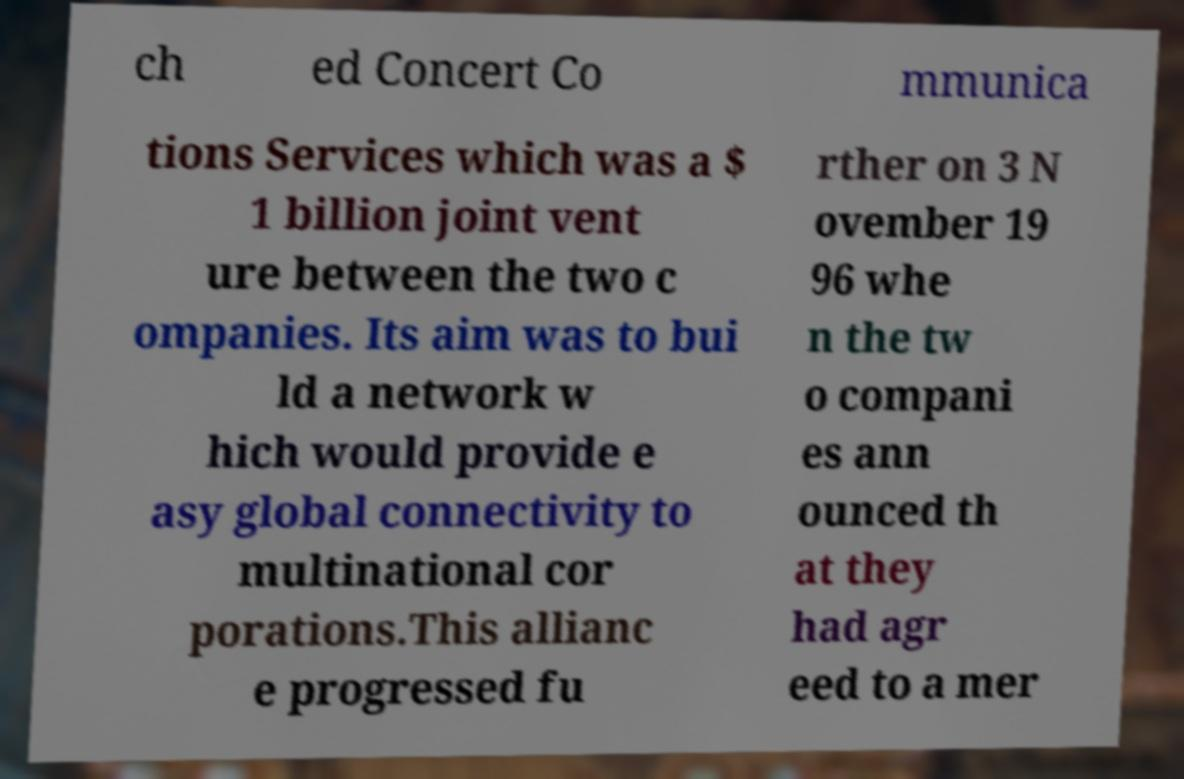Please read and relay the text visible in this image. What does it say? ch ed Concert Co mmunica tions Services which was a $ 1 billion joint vent ure between the two c ompanies. Its aim was to bui ld a network w hich would provide e asy global connectivity to multinational cor porations.This allianc e progressed fu rther on 3 N ovember 19 96 whe n the tw o compani es ann ounced th at they had agr eed to a mer 